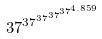<formula> <loc_0><loc_0><loc_500><loc_500>3 7 ^ { 3 7 ^ { 3 7 ^ { 3 7 ^ { 3 7 ^ { 4 . 8 5 9 } } } } }</formula> 